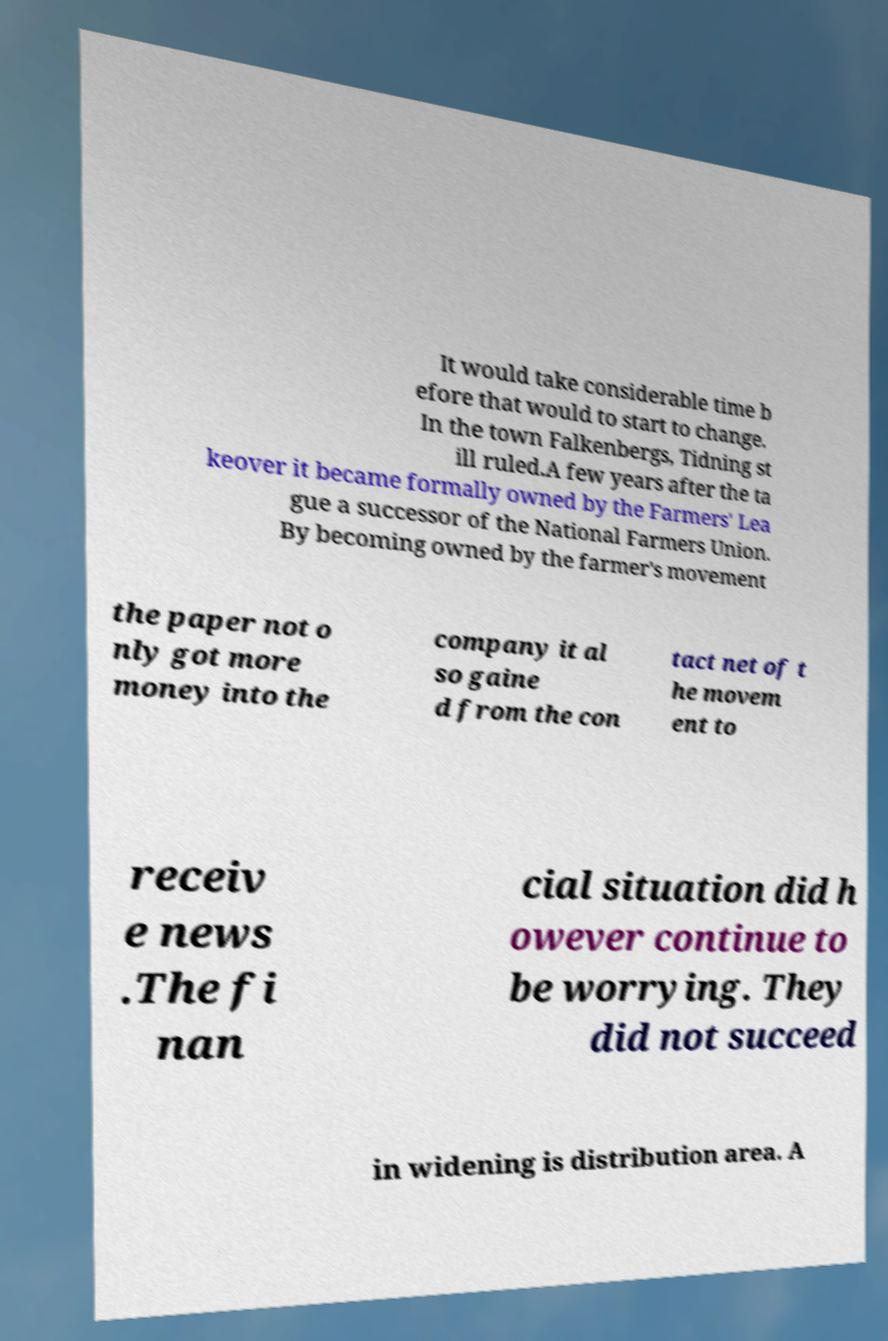Could you assist in decoding the text presented in this image and type it out clearly? It would take considerable time b efore that would to start to change. In the town Falkenbergs, Tidning st ill ruled.A few years after the ta keover it became formally owned by the Farmers' Lea gue a successor of the National Farmers Union. By becoming owned by the farmer's movement the paper not o nly got more money into the company it al so gaine d from the con tact net of t he movem ent to receiv e news .The fi nan cial situation did h owever continue to be worrying. They did not succeed in widening is distribution area. A 